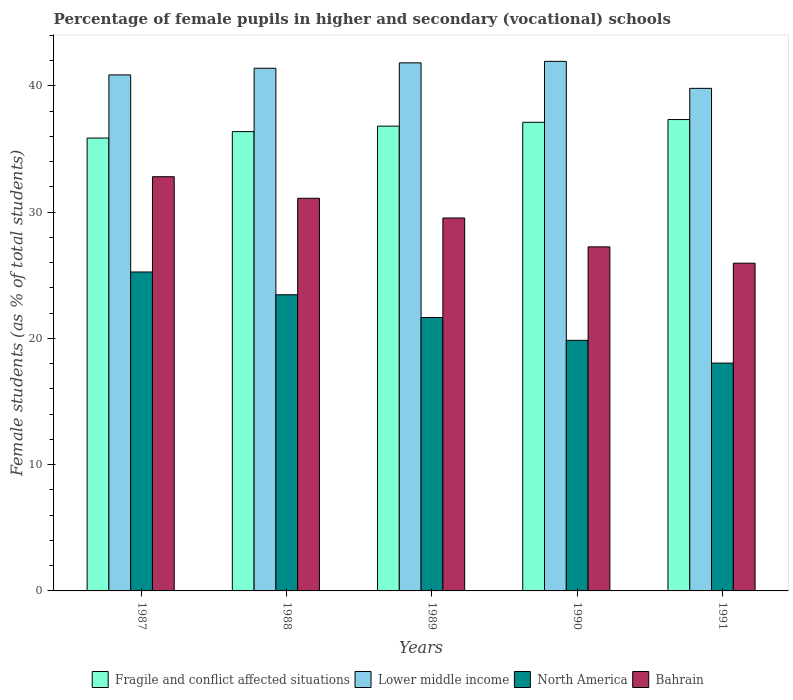Are the number of bars per tick equal to the number of legend labels?
Keep it short and to the point. Yes. How many bars are there on the 4th tick from the left?
Your answer should be very brief. 4. What is the label of the 2nd group of bars from the left?
Offer a terse response. 1988. What is the percentage of female pupils in higher and secondary schools in Bahrain in 1987?
Provide a short and direct response. 32.8. Across all years, what is the maximum percentage of female pupils in higher and secondary schools in Lower middle income?
Provide a succinct answer. 41.94. Across all years, what is the minimum percentage of female pupils in higher and secondary schools in Lower middle income?
Keep it short and to the point. 39.8. In which year was the percentage of female pupils in higher and secondary schools in Lower middle income maximum?
Ensure brevity in your answer.  1990. What is the total percentage of female pupils in higher and secondary schools in Fragile and conflict affected situations in the graph?
Provide a short and direct response. 183.48. What is the difference between the percentage of female pupils in higher and secondary schools in Fragile and conflict affected situations in 1988 and that in 1991?
Offer a very short reply. -0.96. What is the difference between the percentage of female pupils in higher and secondary schools in Fragile and conflict affected situations in 1991 and the percentage of female pupils in higher and secondary schools in North America in 1990?
Ensure brevity in your answer.  17.48. What is the average percentage of female pupils in higher and secondary schools in Lower middle income per year?
Provide a short and direct response. 41.16. In the year 1989, what is the difference between the percentage of female pupils in higher and secondary schools in Fragile and conflict affected situations and percentage of female pupils in higher and secondary schools in North America?
Provide a short and direct response. 15.16. What is the ratio of the percentage of female pupils in higher and secondary schools in Bahrain in 1987 to that in 1991?
Ensure brevity in your answer.  1.26. Is the percentage of female pupils in higher and secondary schools in Fragile and conflict affected situations in 1987 less than that in 1988?
Ensure brevity in your answer.  Yes. Is the difference between the percentage of female pupils in higher and secondary schools in Fragile and conflict affected situations in 1987 and 1991 greater than the difference between the percentage of female pupils in higher and secondary schools in North America in 1987 and 1991?
Your answer should be very brief. No. What is the difference between the highest and the second highest percentage of female pupils in higher and secondary schools in Lower middle income?
Provide a short and direct response. 0.12. What is the difference between the highest and the lowest percentage of female pupils in higher and secondary schools in North America?
Ensure brevity in your answer.  7.22. Is the sum of the percentage of female pupils in higher and secondary schools in Fragile and conflict affected situations in 1987 and 1989 greater than the maximum percentage of female pupils in higher and secondary schools in Bahrain across all years?
Your answer should be very brief. Yes. Is it the case that in every year, the sum of the percentage of female pupils in higher and secondary schools in Fragile and conflict affected situations and percentage of female pupils in higher and secondary schools in North America is greater than the sum of percentage of female pupils in higher and secondary schools in Bahrain and percentage of female pupils in higher and secondary schools in Lower middle income?
Make the answer very short. Yes. What does the 1st bar from the left in 1991 represents?
Offer a terse response. Fragile and conflict affected situations. Is it the case that in every year, the sum of the percentage of female pupils in higher and secondary schools in Bahrain and percentage of female pupils in higher and secondary schools in Fragile and conflict affected situations is greater than the percentage of female pupils in higher and secondary schools in Lower middle income?
Ensure brevity in your answer.  Yes. What is the difference between two consecutive major ticks on the Y-axis?
Offer a very short reply. 10. Where does the legend appear in the graph?
Make the answer very short. Bottom center. How many legend labels are there?
Provide a short and direct response. 4. How are the legend labels stacked?
Offer a very short reply. Horizontal. What is the title of the graph?
Provide a succinct answer. Percentage of female pupils in higher and secondary (vocational) schools. What is the label or title of the X-axis?
Your answer should be very brief. Years. What is the label or title of the Y-axis?
Make the answer very short. Female students (as % of total students). What is the Female students (as % of total students) in Fragile and conflict affected situations in 1987?
Make the answer very short. 35.86. What is the Female students (as % of total students) of Lower middle income in 1987?
Offer a very short reply. 40.86. What is the Female students (as % of total students) in North America in 1987?
Provide a succinct answer. 25.26. What is the Female students (as % of total students) of Bahrain in 1987?
Keep it short and to the point. 32.8. What is the Female students (as % of total students) of Fragile and conflict affected situations in 1988?
Provide a succinct answer. 36.37. What is the Female students (as % of total students) of Lower middle income in 1988?
Offer a terse response. 41.39. What is the Female students (as % of total students) in North America in 1988?
Keep it short and to the point. 23.45. What is the Female students (as % of total students) in Bahrain in 1988?
Your response must be concise. 31.09. What is the Female students (as % of total students) in Fragile and conflict affected situations in 1989?
Provide a short and direct response. 36.8. What is the Female students (as % of total students) of Lower middle income in 1989?
Offer a terse response. 41.82. What is the Female students (as % of total students) of North America in 1989?
Give a very brief answer. 21.65. What is the Female students (as % of total students) in Bahrain in 1989?
Offer a terse response. 29.53. What is the Female students (as % of total students) of Fragile and conflict affected situations in 1990?
Your answer should be compact. 37.11. What is the Female students (as % of total students) of Lower middle income in 1990?
Ensure brevity in your answer.  41.94. What is the Female students (as % of total students) in North America in 1990?
Make the answer very short. 19.84. What is the Female students (as % of total students) in Bahrain in 1990?
Your answer should be very brief. 27.25. What is the Female students (as % of total students) of Fragile and conflict affected situations in 1991?
Keep it short and to the point. 37.33. What is the Female students (as % of total students) of Lower middle income in 1991?
Your response must be concise. 39.8. What is the Female students (as % of total students) of North America in 1991?
Offer a very short reply. 18.04. What is the Female students (as % of total students) of Bahrain in 1991?
Make the answer very short. 25.95. Across all years, what is the maximum Female students (as % of total students) in Fragile and conflict affected situations?
Your answer should be very brief. 37.33. Across all years, what is the maximum Female students (as % of total students) of Lower middle income?
Offer a very short reply. 41.94. Across all years, what is the maximum Female students (as % of total students) of North America?
Offer a terse response. 25.26. Across all years, what is the maximum Female students (as % of total students) in Bahrain?
Offer a very short reply. 32.8. Across all years, what is the minimum Female students (as % of total students) of Fragile and conflict affected situations?
Offer a terse response. 35.86. Across all years, what is the minimum Female students (as % of total students) of Lower middle income?
Your response must be concise. 39.8. Across all years, what is the minimum Female students (as % of total students) of North America?
Offer a very short reply. 18.04. Across all years, what is the minimum Female students (as % of total students) in Bahrain?
Provide a succinct answer. 25.95. What is the total Female students (as % of total students) in Fragile and conflict affected situations in the graph?
Your response must be concise. 183.48. What is the total Female students (as % of total students) of Lower middle income in the graph?
Your response must be concise. 205.81. What is the total Female students (as % of total students) of North America in the graph?
Your answer should be compact. 108.24. What is the total Female students (as % of total students) in Bahrain in the graph?
Provide a short and direct response. 146.62. What is the difference between the Female students (as % of total students) in Fragile and conflict affected situations in 1987 and that in 1988?
Provide a short and direct response. -0.51. What is the difference between the Female students (as % of total students) in Lower middle income in 1987 and that in 1988?
Your response must be concise. -0.53. What is the difference between the Female students (as % of total students) of North America in 1987 and that in 1988?
Provide a succinct answer. 1.8. What is the difference between the Female students (as % of total students) of Bahrain in 1987 and that in 1988?
Your response must be concise. 1.71. What is the difference between the Female students (as % of total students) in Fragile and conflict affected situations in 1987 and that in 1989?
Provide a short and direct response. -0.94. What is the difference between the Female students (as % of total students) in Lower middle income in 1987 and that in 1989?
Ensure brevity in your answer.  -0.95. What is the difference between the Female students (as % of total students) of North America in 1987 and that in 1989?
Provide a short and direct response. 3.61. What is the difference between the Female students (as % of total students) in Bahrain in 1987 and that in 1989?
Keep it short and to the point. 3.27. What is the difference between the Female students (as % of total students) of Fragile and conflict affected situations in 1987 and that in 1990?
Your answer should be very brief. -1.25. What is the difference between the Female students (as % of total students) in Lower middle income in 1987 and that in 1990?
Offer a very short reply. -1.07. What is the difference between the Female students (as % of total students) of North America in 1987 and that in 1990?
Your response must be concise. 5.41. What is the difference between the Female students (as % of total students) in Bahrain in 1987 and that in 1990?
Your answer should be very brief. 5.56. What is the difference between the Female students (as % of total students) in Fragile and conflict affected situations in 1987 and that in 1991?
Offer a very short reply. -1.47. What is the difference between the Female students (as % of total students) of Lower middle income in 1987 and that in 1991?
Keep it short and to the point. 1.06. What is the difference between the Female students (as % of total students) in North America in 1987 and that in 1991?
Keep it short and to the point. 7.22. What is the difference between the Female students (as % of total students) of Bahrain in 1987 and that in 1991?
Ensure brevity in your answer.  6.85. What is the difference between the Female students (as % of total students) of Fragile and conflict affected situations in 1988 and that in 1989?
Provide a succinct answer. -0.43. What is the difference between the Female students (as % of total students) in Lower middle income in 1988 and that in 1989?
Make the answer very short. -0.43. What is the difference between the Female students (as % of total students) in North America in 1988 and that in 1989?
Offer a terse response. 1.8. What is the difference between the Female students (as % of total students) of Bahrain in 1988 and that in 1989?
Provide a short and direct response. 1.56. What is the difference between the Female students (as % of total students) in Fragile and conflict affected situations in 1988 and that in 1990?
Ensure brevity in your answer.  -0.74. What is the difference between the Female students (as % of total students) of Lower middle income in 1988 and that in 1990?
Keep it short and to the point. -0.55. What is the difference between the Female students (as % of total students) of North America in 1988 and that in 1990?
Your answer should be compact. 3.61. What is the difference between the Female students (as % of total students) of Bahrain in 1988 and that in 1990?
Your answer should be compact. 3.85. What is the difference between the Female students (as % of total students) of Fragile and conflict affected situations in 1988 and that in 1991?
Give a very brief answer. -0.96. What is the difference between the Female students (as % of total students) of Lower middle income in 1988 and that in 1991?
Your answer should be very brief. 1.59. What is the difference between the Female students (as % of total students) of North America in 1988 and that in 1991?
Keep it short and to the point. 5.41. What is the difference between the Female students (as % of total students) in Bahrain in 1988 and that in 1991?
Provide a succinct answer. 5.14. What is the difference between the Female students (as % of total students) in Fragile and conflict affected situations in 1989 and that in 1990?
Make the answer very short. -0.31. What is the difference between the Female students (as % of total students) in Lower middle income in 1989 and that in 1990?
Offer a very short reply. -0.12. What is the difference between the Female students (as % of total students) in North America in 1989 and that in 1990?
Ensure brevity in your answer.  1.8. What is the difference between the Female students (as % of total students) of Bahrain in 1989 and that in 1990?
Your answer should be very brief. 2.29. What is the difference between the Female students (as % of total students) in Fragile and conflict affected situations in 1989 and that in 1991?
Offer a terse response. -0.52. What is the difference between the Female students (as % of total students) of Lower middle income in 1989 and that in 1991?
Offer a very short reply. 2.02. What is the difference between the Female students (as % of total students) in North America in 1989 and that in 1991?
Offer a very short reply. 3.61. What is the difference between the Female students (as % of total students) of Bahrain in 1989 and that in 1991?
Your answer should be compact. 3.58. What is the difference between the Female students (as % of total students) in Fragile and conflict affected situations in 1990 and that in 1991?
Make the answer very short. -0.22. What is the difference between the Female students (as % of total students) in Lower middle income in 1990 and that in 1991?
Give a very brief answer. 2.14. What is the difference between the Female students (as % of total students) in North America in 1990 and that in 1991?
Offer a very short reply. 1.8. What is the difference between the Female students (as % of total students) of Bahrain in 1990 and that in 1991?
Make the answer very short. 1.29. What is the difference between the Female students (as % of total students) in Fragile and conflict affected situations in 1987 and the Female students (as % of total students) in Lower middle income in 1988?
Your answer should be very brief. -5.53. What is the difference between the Female students (as % of total students) in Fragile and conflict affected situations in 1987 and the Female students (as % of total students) in North America in 1988?
Ensure brevity in your answer.  12.41. What is the difference between the Female students (as % of total students) of Fragile and conflict affected situations in 1987 and the Female students (as % of total students) of Bahrain in 1988?
Provide a short and direct response. 4.77. What is the difference between the Female students (as % of total students) in Lower middle income in 1987 and the Female students (as % of total students) in North America in 1988?
Make the answer very short. 17.41. What is the difference between the Female students (as % of total students) of Lower middle income in 1987 and the Female students (as % of total students) of Bahrain in 1988?
Your answer should be compact. 9.77. What is the difference between the Female students (as % of total students) in North America in 1987 and the Female students (as % of total students) in Bahrain in 1988?
Offer a terse response. -5.84. What is the difference between the Female students (as % of total students) of Fragile and conflict affected situations in 1987 and the Female students (as % of total students) of Lower middle income in 1989?
Ensure brevity in your answer.  -5.96. What is the difference between the Female students (as % of total students) in Fragile and conflict affected situations in 1987 and the Female students (as % of total students) in North America in 1989?
Give a very brief answer. 14.21. What is the difference between the Female students (as % of total students) of Fragile and conflict affected situations in 1987 and the Female students (as % of total students) of Bahrain in 1989?
Provide a short and direct response. 6.33. What is the difference between the Female students (as % of total students) in Lower middle income in 1987 and the Female students (as % of total students) in North America in 1989?
Provide a short and direct response. 19.21. What is the difference between the Female students (as % of total students) of Lower middle income in 1987 and the Female students (as % of total students) of Bahrain in 1989?
Offer a terse response. 11.33. What is the difference between the Female students (as % of total students) of North America in 1987 and the Female students (as % of total students) of Bahrain in 1989?
Ensure brevity in your answer.  -4.27. What is the difference between the Female students (as % of total students) in Fragile and conflict affected situations in 1987 and the Female students (as % of total students) in Lower middle income in 1990?
Give a very brief answer. -6.07. What is the difference between the Female students (as % of total students) in Fragile and conflict affected situations in 1987 and the Female students (as % of total students) in North America in 1990?
Your answer should be compact. 16.02. What is the difference between the Female students (as % of total students) of Fragile and conflict affected situations in 1987 and the Female students (as % of total students) of Bahrain in 1990?
Provide a succinct answer. 8.62. What is the difference between the Female students (as % of total students) in Lower middle income in 1987 and the Female students (as % of total students) in North America in 1990?
Make the answer very short. 21.02. What is the difference between the Female students (as % of total students) in Lower middle income in 1987 and the Female students (as % of total students) in Bahrain in 1990?
Your answer should be compact. 13.62. What is the difference between the Female students (as % of total students) of North America in 1987 and the Female students (as % of total students) of Bahrain in 1990?
Ensure brevity in your answer.  -1.99. What is the difference between the Female students (as % of total students) of Fragile and conflict affected situations in 1987 and the Female students (as % of total students) of Lower middle income in 1991?
Ensure brevity in your answer.  -3.94. What is the difference between the Female students (as % of total students) in Fragile and conflict affected situations in 1987 and the Female students (as % of total students) in North America in 1991?
Your answer should be very brief. 17.82. What is the difference between the Female students (as % of total students) of Fragile and conflict affected situations in 1987 and the Female students (as % of total students) of Bahrain in 1991?
Keep it short and to the point. 9.91. What is the difference between the Female students (as % of total students) in Lower middle income in 1987 and the Female students (as % of total students) in North America in 1991?
Make the answer very short. 22.82. What is the difference between the Female students (as % of total students) of Lower middle income in 1987 and the Female students (as % of total students) of Bahrain in 1991?
Your answer should be compact. 14.91. What is the difference between the Female students (as % of total students) of North America in 1987 and the Female students (as % of total students) of Bahrain in 1991?
Offer a very short reply. -0.69. What is the difference between the Female students (as % of total students) in Fragile and conflict affected situations in 1988 and the Female students (as % of total students) in Lower middle income in 1989?
Offer a terse response. -5.44. What is the difference between the Female students (as % of total students) in Fragile and conflict affected situations in 1988 and the Female students (as % of total students) in North America in 1989?
Provide a short and direct response. 14.72. What is the difference between the Female students (as % of total students) in Fragile and conflict affected situations in 1988 and the Female students (as % of total students) in Bahrain in 1989?
Offer a terse response. 6.84. What is the difference between the Female students (as % of total students) of Lower middle income in 1988 and the Female students (as % of total students) of North America in 1989?
Offer a very short reply. 19.74. What is the difference between the Female students (as % of total students) in Lower middle income in 1988 and the Female students (as % of total students) in Bahrain in 1989?
Keep it short and to the point. 11.86. What is the difference between the Female students (as % of total students) in North America in 1988 and the Female students (as % of total students) in Bahrain in 1989?
Keep it short and to the point. -6.08. What is the difference between the Female students (as % of total students) in Fragile and conflict affected situations in 1988 and the Female students (as % of total students) in Lower middle income in 1990?
Offer a terse response. -5.56. What is the difference between the Female students (as % of total students) of Fragile and conflict affected situations in 1988 and the Female students (as % of total students) of North America in 1990?
Offer a terse response. 16.53. What is the difference between the Female students (as % of total students) of Fragile and conflict affected situations in 1988 and the Female students (as % of total students) of Bahrain in 1990?
Offer a very short reply. 9.13. What is the difference between the Female students (as % of total students) of Lower middle income in 1988 and the Female students (as % of total students) of North America in 1990?
Your answer should be very brief. 21.55. What is the difference between the Female students (as % of total students) of Lower middle income in 1988 and the Female students (as % of total students) of Bahrain in 1990?
Your answer should be compact. 14.14. What is the difference between the Female students (as % of total students) of North America in 1988 and the Female students (as % of total students) of Bahrain in 1990?
Offer a terse response. -3.79. What is the difference between the Female students (as % of total students) in Fragile and conflict affected situations in 1988 and the Female students (as % of total students) in Lower middle income in 1991?
Make the answer very short. -3.43. What is the difference between the Female students (as % of total students) in Fragile and conflict affected situations in 1988 and the Female students (as % of total students) in North America in 1991?
Ensure brevity in your answer.  18.33. What is the difference between the Female students (as % of total students) in Fragile and conflict affected situations in 1988 and the Female students (as % of total students) in Bahrain in 1991?
Give a very brief answer. 10.42. What is the difference between the Female students (as % of total students) of Lower middle income in 1988 and the Female students (as % of total students) of North America in 1991?
Provide a succinct answer. 23.35. What is the difference between the Female students (as % of total students) of Lower middle income in 1988 and the Female students (as % of total students) of Bahrain in 1991?
Keep it short and to the point. 15.44. What is the difference between the Female students (as % of total students) in North America in 1988 and the Female students (as % of total students) in Bahrain in 1991?
Your answer should be compact. -2.5. What is the difference between the Female students (as % of total students) in Fragile and conflict affected situations in 1989 and the Female students (as % of total students) in Lower middle income in 1990?
Your answer should be compact. -5.13. What is the difference between the Female students (as % of total students) in Fragile and conflict affected situations in 1989 and the Female students (as % of total students) in North America in 1990?
Make the answer very short. 16.96. What is the difference between the Female students (as % of total students) in Fragile and conflict affected situations in 1989 and the Female students (as % of total students) in Bahrain in 1990?
Keep it short and to the point. 9.56. What is the difference between the Female students (as % of total students) in Lower middle income in 1989 and the Female students (as % of total students) in North America in 1990?
Make the answer very short. 21.97. What is the difference between the Female students (as % of total students) in Lower middle income in 1989 and the Female students (as % of total students) in Bahrain in 1990?
Your answer should be very brief. 14.57. What is the difference between the Female students (as % of total students) in North America in 1989 and the Female students (as % of total students) in Bahrain in 1990?
Your answer should be very brief. -5.6. What is the difference between the Female students (as % of total students) of Fragile and conflict affected situations in 1989 and the Female students (as % of total students) of Lower middle income in 1991?
Your response must be concise. -2.99. What is the difference between the Female students (as % of total students) in Fragile and conflict affected situations in 1989 and the Female students (as % of total students) in North America in 1991?
Provide a succinct answer. 18.76. What is the difference between the Female students (as % of total students) of Fragile and conflict affected situations in 1989 and the Female students (as % of total students) of Bahrain in 1991?
Provide a succinct answer. 10.85. What is the difference between the Female students (as % of total students) in Lower middle income in 1989 and the Female students (as % of total students) in North America in 1991?
Ensure brevity in your answer.  23.78. What is the difference between the Female students (as % of total students) of Lower middle income in 1989 and the Female students (as % of total students) of Bahrain in 1991?
Your answer should be very brief. 15.87. What is the difference between the Female students (as % of total students) in North America in 1989 and the Female students (as % of total students) in Bahrain in 1991?
Your answer should be compact. -4.3. What is the difference between the Female students (as % of total students) in Fragile and conflict affected situations in 1990 and the Female students (as % of total students) in Lower middle income in 1991?
Your answer should be very brief. -2.69. What is the difference between the Female students (as % of total students) of Fragile and conflict affected situations in 1990 and the Female students (as % of total students) of North America in 1991?
Offer a very short reply. 19.07. What is the difference between the Female students (as % of total students) in Fragile and conflict affected situations in 1990 and the Female students (as % of total students) in Bahrain in 1991?
Your answer should be compact. 11.16. What is the difference between the Female students (as % of total students) in Lower middle income in 1990 and the Female students (as % of total students) in North America in 1991?
Give a very brief answer. 23.9. What is the difference between the Female students (as % of total students) of Lower middle income in 1990 and the Female students (as % of total students) of Bahrain in 1991?
Offer a terse response. 15.98. What is the difference between the Female students (as % of total students) of North America in 1990 and the Female students (as % of total students) of Bahrain in 1991?
Keep it short and to the point. -6.11. What is the average Female students (as % of total students) of Fragile and conflict affected situations per year?
Your answer should be very brief. 36.7. What is the average Female students (as % of total students) in Lower middle income per year?
Ensure brevity in your answer.  41.16. What is the average Female students (as % of total students) in North America per year?
Your answer should be very brief. 21.65. What is the average Female students (as % of total students) of Bahrain per year?
Give a very brief answer. 29.32. In the year 1987, what is the difference between the Female students (as % of total students) in Fragile and conflict affected situations and Female students (as % of total students) in Lower middle income?
Your answer should be compact. -5. In the year 1987, what is the difference between the Female students (as % of total students) in Fragile and conflict affected situations and Female students (as % of total students) in North America?
Provide a short and direct response. 10.6. In the year 1987, what is the difference between the Female students (as % of total students) of Fragile and conflict affected situations and Female students (as % of total students) of Bahrain?
Provide a short and direct response. 3.06. In the year 1987, what is the difference between the Female students (as % of total students) in Lower middle income and Female students (as % of total students) in North America?
Your answer should be compact. 15.61. In the year 1987, what is the difference between the Female students (as % of total students) in Lower middle income and Female students (as % of total students) in Bahrain?
Offer a very short reply. 8.06. In the year 1987, what is the difference between the Female students (as % of total students) in North America and Female students (as % of total students) in Bahrain?
Ensure brevity in your answer.  -7.54. In the year 1988, what is the difference between the Female students (as % of total students) of Fragile and conflict affected situations and Female students (as % of total students) of Lower middle income?
Keep it short and to the point. -5.02. In the year 1988, what is the difference between the Female students (as % of total students) in Fragile and conflict affected situations and Female students (as % of total students) in North America?
Your response must be concise. 12.92. In the year 1988, what is the difference between the Female students (as % of total students) in Fragile and conflict affected situations and Female students (as % of total students) in Bahrain?
Ensure brevity in your answer.  5.28. In the year 1988, what is the difference between the Female students (as % of total students) of Lower middle income and Female students (as % of total students) of North America?
Offer a very short reply. 17.94. In the year 1988, what is the difference between the Female students (as % of total students) of Lower middle income and Female students (as % of total students) of Bahrain?
Provide a succinct answer. 10.3. In the year 1988, what is the difference between the Female students (as % of total students) in North America and Female students (as % of total students) in Bahrain?
Make the answer very short. -7.64. In the year 1989, what is the difference between the Female students (as % of total students) in Fragile and conflict affected situations and Female students (as % of total students) in Lower middle income?
Offer a terse response. -5.01. In the year 1989, what is the difference between the Female students (as % of total students) of Fragile and conflict affected situations and Female students (as % of total students) of North America?
Offer a terse response. 15.16. In the year 1989, what is the difference between the Female students (as % of total students) in Fragile and conflict affected situations and Female students (as % of total students) in Bahrain?
Offer a very short reply. 7.27. In the year 1989, what is the difference between the Female students (as % of total students) in Lower middle income and Female students (as % of total students) in North America?
Provide a succinct answer. 20.17. In the year 1989, what is the difference between the Female students (as % of total students) of Lower middle income and Female students (as % of total students) of Bahrain?
Your response must be concise. 12.29. In the year 1989, what is the difference between the Female students (as % of total students) in North America and Female students (as % of total students) in Bahrain?
Offer a very short reply. -7.88. In the year 1990, what is the difference between the Female students (as % of total students) of Fragile and conflict affected situations and Female students (as % of total students) of Lower middle income?
Offer a terse response. -4.83. In the year 1990, what is the difference between the Female students (as % of total students) of Fragile and conflict affected situations and Female students (as % of total students) of North America?
Make the answer very short. 17.27. In the year 1990, what is the difference between the Female students (as % of total students) in Fragile and conflict affected situations and Female students (as % of total students) in Bahrain?
Offer a terse response. 9.87. In the year 1990, what is the difference between the Female students (as % of total students) of Lower middle income and Female students (as % of total students) of North America?
Provide a short and direct response. 22.09. In the year 1990, what is the difference between the Female students (as % of total students) of Lower middle income and Female students (as % of total students) of Bahrain?
Give a very brief answer. 14.69. In the year 1990, what is the difference between the Female students (as % of total students) of North America and Female students (as % of total students) of Bahrain?
Offer a terse response. -7.4. In the year 1991, what is the difference between the Female students (as % of total students) of Fragile and conflict affected situations and Female students (as % of total students) of Lower middle income?
Your response must be concise. -2.47. In the year 1991, what is the difference between the Female students (as % of total students) of Fragile and conflict affected situations and Female students (as % of total students) of North America?
Your answer should be compact. 19.29. In the year 1991, what is the difference between the Female students (as % of total students) in Fragile and conflict affected situations and Female students (as % of total students) in Bahrain?
Provide a succinct answer. 11.38. In the year 1991, what is the difference between the Female students (as % of total students) of Lower middle income and Female students (as % of total students) of North America?
Provide a short and direct response. 21.76. In the year 1991, what is the difference between the Female students (as % of total students) in Lower middle income and Female students (as % of total students) in Bahrain?
Offer a very short reply. 13.85. In the year 1991, what is the difference between the Female students (as % of total students) in North America and Female students (as % of total students) in Bahrain?
Offer a very short reply. -7.91. What is the ratio of the Female students (as % of total students) of Lower middle income in 1987 to that in 1988?
Your response must be concise. 0.99. What is the ratio of the Female students (as % of total students) of North America in 1987 to that in 1988?
Keep it short and to the point. 1.08. What is the ratio of the Female students (as % of total students) of Bahrain in 1987 to that in 1988?
Provide a short and direct response. 1.05. What is the ratio of the Female students (as % of total students) of Fragile and conflict affected situations in 1987 to that in 1989?
Offer a very short reply. 0.97. What is the ratio of the Female students (as % of total students) in Lower middle income in 1987 to that in 1989?
Make the answer very short. 0.98. What is the ratio of the Female students (as % of total students) in North America in 1987 to that in 1989?
Offer a very short reply. 1.17. What is the ratio of the Female students (as % of total students) in Bahrain in 1987 to that in 1989?
Your answer should be very brief. 1.11. What is the ratio of the Female students (as % of total students) of Fragile and conflict affected situations in 1987 to that in 1990?
Make the answer very short. 0.97. What is the ratio of the Female students (as % of total students) in Lower middle income in 1987 to that in 1990?
Your answer should be very brief. 0.97. What is the ratio of the Female students (as % of total students) of North America in 1987 to that in 1990?
Offer a very short reply. 1.27. What is the ratio of the Female students (as % of total students) of Bahrain in 1987 to that in 1990?
Offer a very short reply. 1.2. What is the ratio of the Female students (as % of total students) of Fragile and conflict affected situations in 1987 to that in 1991?
Give a very brief answer. 0.96. What is the ratio of the Female students (as % of total students) in Lower middle income in 1987 to that in 1991?
Give a very brief answer. 1.03. What is the ratio of the Female students (as % of total students) in Bahrain in 1987 to that in 1991?
Your answer should be compact. 1.26. What is the ratio of the Female students (as % of total students) of Fragile and conflict affected situations in 1988 to that in 1989?
Ensure brevity in your answer.  0.99. What is the ratio of the Female students (as % of total students) of North America in 1988 to that in 1989?
Provide a short and direct response. 1.08. What is the ratio of the Female students (as % of total students) of Bahrain in 1988 to that in 1989?
Your answer should be compact. 1.05. What is the ratio of the Female students (as % of total students) in Fragile and conflict affected situations in 1988 to that in 1990?
Provide a short and direct response. 0.98. What is the ratio of the Female students (as % of total students) of North America in 1988 to that in 1990?
Your answer should be compact. 1.18. What is the ratio of the Female students (as % of total students) in Bahrain in 1988 to that in 1990?
Make the answer very short. 1.14. What is the ratio of the Female students (as % of total students) in Fragile and conflict affected situations in 1988 to that in 1991?
Keep it short and to the point. 0.97. What is the ratio of the Female students (as % of total students) in Lower middle income in 1988 to that in 1991?
Make the answer very short. 1.04. What is the ratio of the Female students (as % of total students) of Bahrain in 1988 to that in 1991?
Offer a terse response. 1.2. What is the ratio of the Female students (as % of total students) in Fragile and conflict affected situations in 1989 to that in 1990?
Ensure brevity in your answer.  0.99. What is the ratio of the Female students (as % of total students) in Bahrain in 1989 to that in 1990?
Provide a succinct answer. 1.08. What is the ratio of the Female students (as % of total students) of Lower middle income in 1989 to that in 1991?
Keep it short and to the point. 1.05. What is the ratio of the Female students (as % of total students) in North America in 1989 to that in 1991?
Your response must be concise. 1.2. What is the ratio of the Female students (as % of total students) of Bahrain in 1989 to that in 1991?
Offer a terse response. 1.14. What is the ratio of the Female students (as % of total students) in Lower middle income in 1990 to that in 1991?
Provide a succinct answer. 1.05. What is the ratio of the Female students (as % of total students) of Bahrain in 1990 to that in 1991?
Give a very brief answer. 1.05. What is the difference between the highest and the second highest Female students (as % of total students) in Fragile and conflict affected situations?
Ensure brevity in your answer.  0.22. What is the difference between the highest and the second highest Female students (as % of total students) in Lower middle income?
Provide a succinct answer. 0.12. What is the difference between the highest and the second highest Female students (as % of total students) of North America?
Keep it short and to the point. 1.8. What is the difference between the highest and the second highest Female students (as % of total students) in Bahrain?
Make the answer very short. 1.71. What is the difference between the highest and the lowest Female students (as % of total students) of Fragile and conflict affected situations?
Your response must be concise. 1.47. What is the difference between the highest and the lowest Female students (as % of total students) in Lower middle income?
Ensure brevity in your answer.  2.14. What is the difference between the highest and the lowest Female students (as % of total students) of North America?
Your answer should be very brief. 7.22. What is the difference between the highest and the lowest Female students (as % of total students) of Bahrain?
Offer a very short reply. 6.85. 